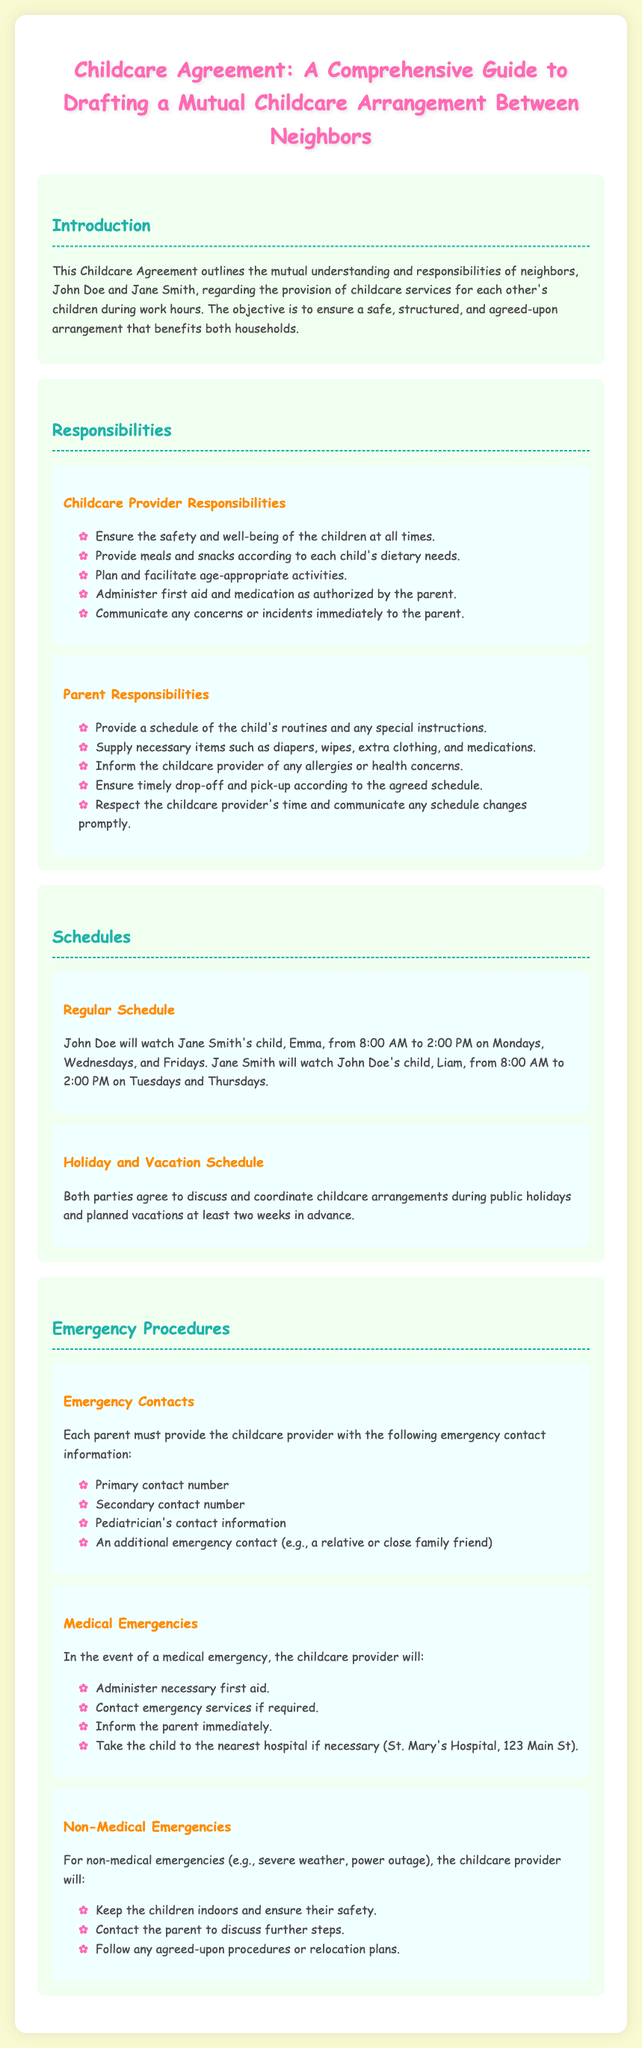What is the main purpose of the Childcare Agreement? The main purpose is to outline the mutual understanding and responsibilities of neighbors regarding childcare services.
Answer: to outline mutual understanding and responsibilities Who is responsible for planning activities? The childcare provider is responsible for planning and facilitating age-appropriate activities.
Answer: childcare provider What time does John watch Emma on Mondays? John watches Emma from 8:00 AM to 2:00 PM on Mondays.
Answer: 8:00 AM to 2:00 PM What should each parent provide in case of an emergency? Each parent must provide the childcare provider with emergency contact information.
Answer: emergency contact information What will the childcare provider do in a medical emergency? In a medical emergency, the childcare provider will administer necessary first aid.
Answer: administer necessary first aid How often must the holiday childcare arrangements be discussed? They must be discussed at least two weeks in advance.
Answer: two weeks What color is used for the section headings? The section headings are colored in a shade of teal (#20B2AA).
Answer: teal What should parents provide related to health concerns? Parents should inform the childcare provider of any allergies or health concerns.
Answer: allergies or health concerns How are non-medical emergencies addressed? For non-medical emergencies, the childcare provider will keep the children indoors and ensure their safety.
Answer: keep the children indoors and ensure their safety 